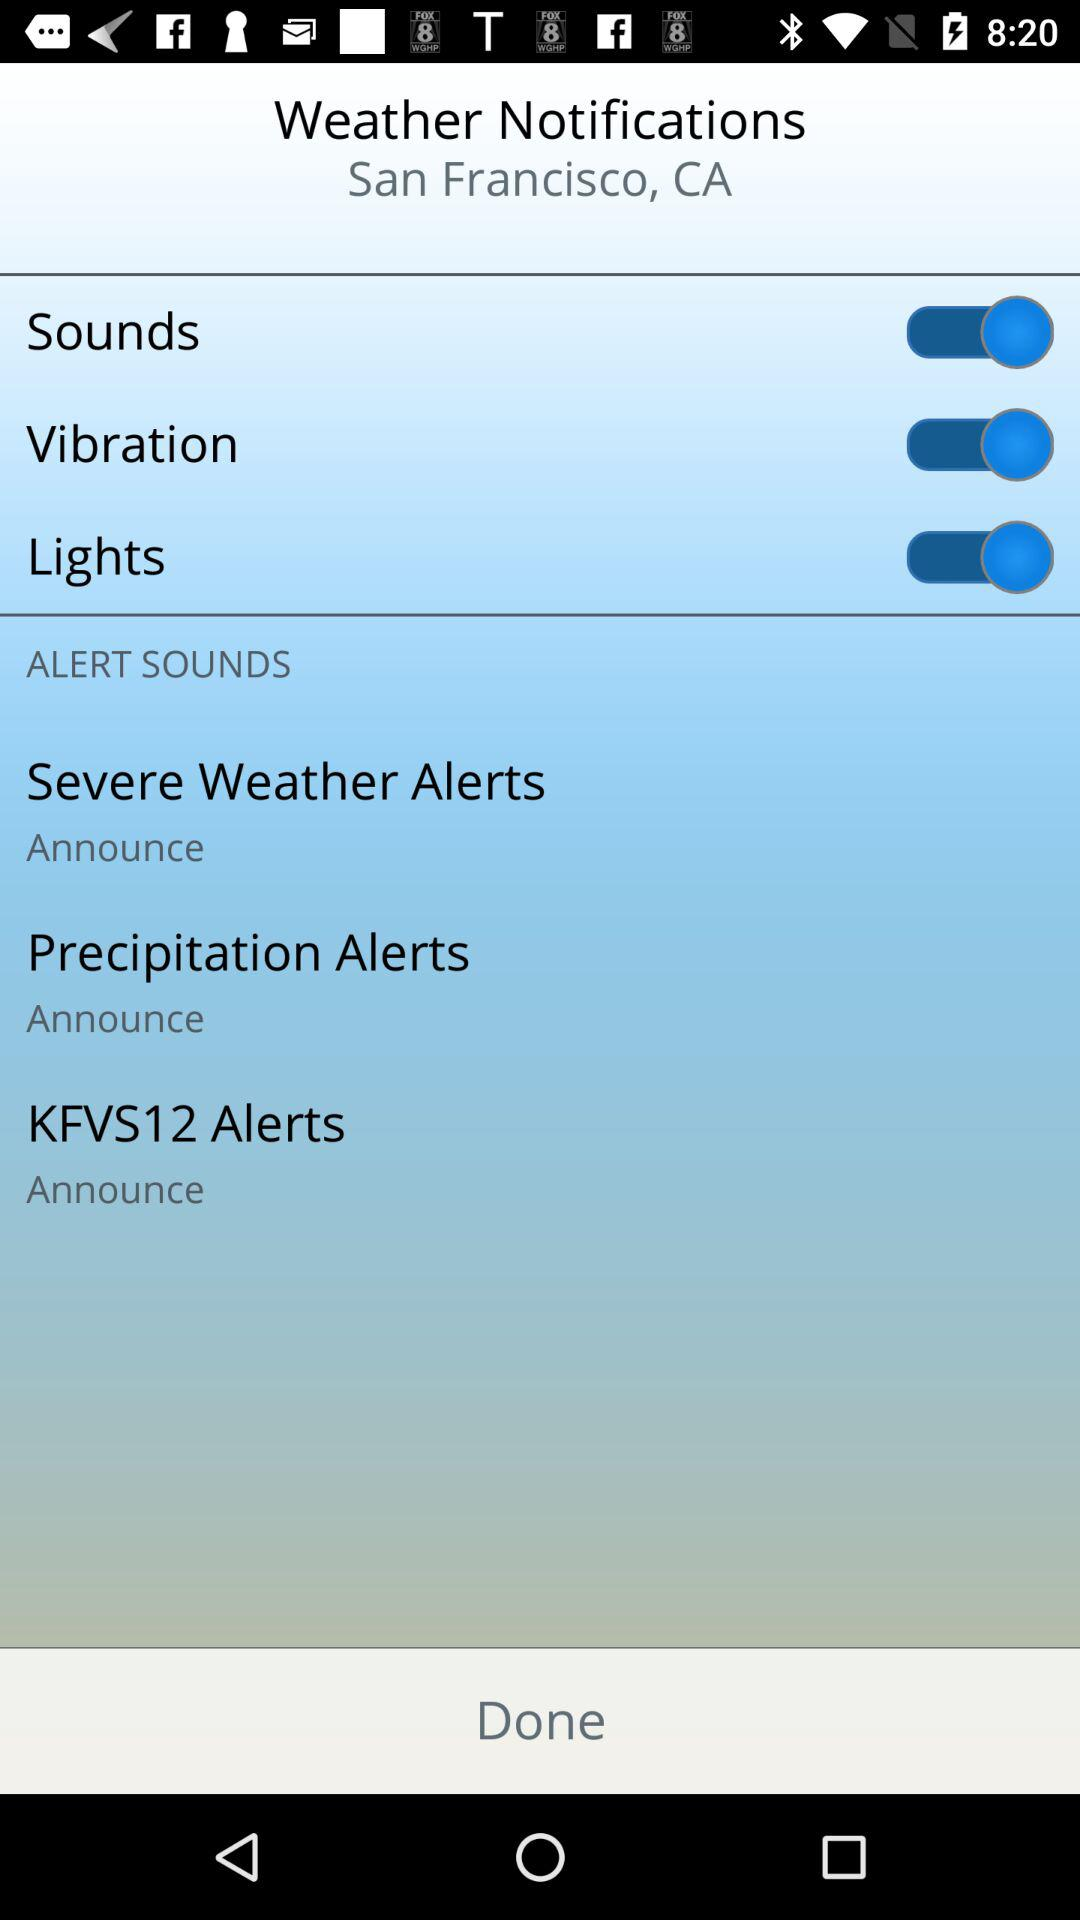What's the status of the "Vibration"? The status is "on". 